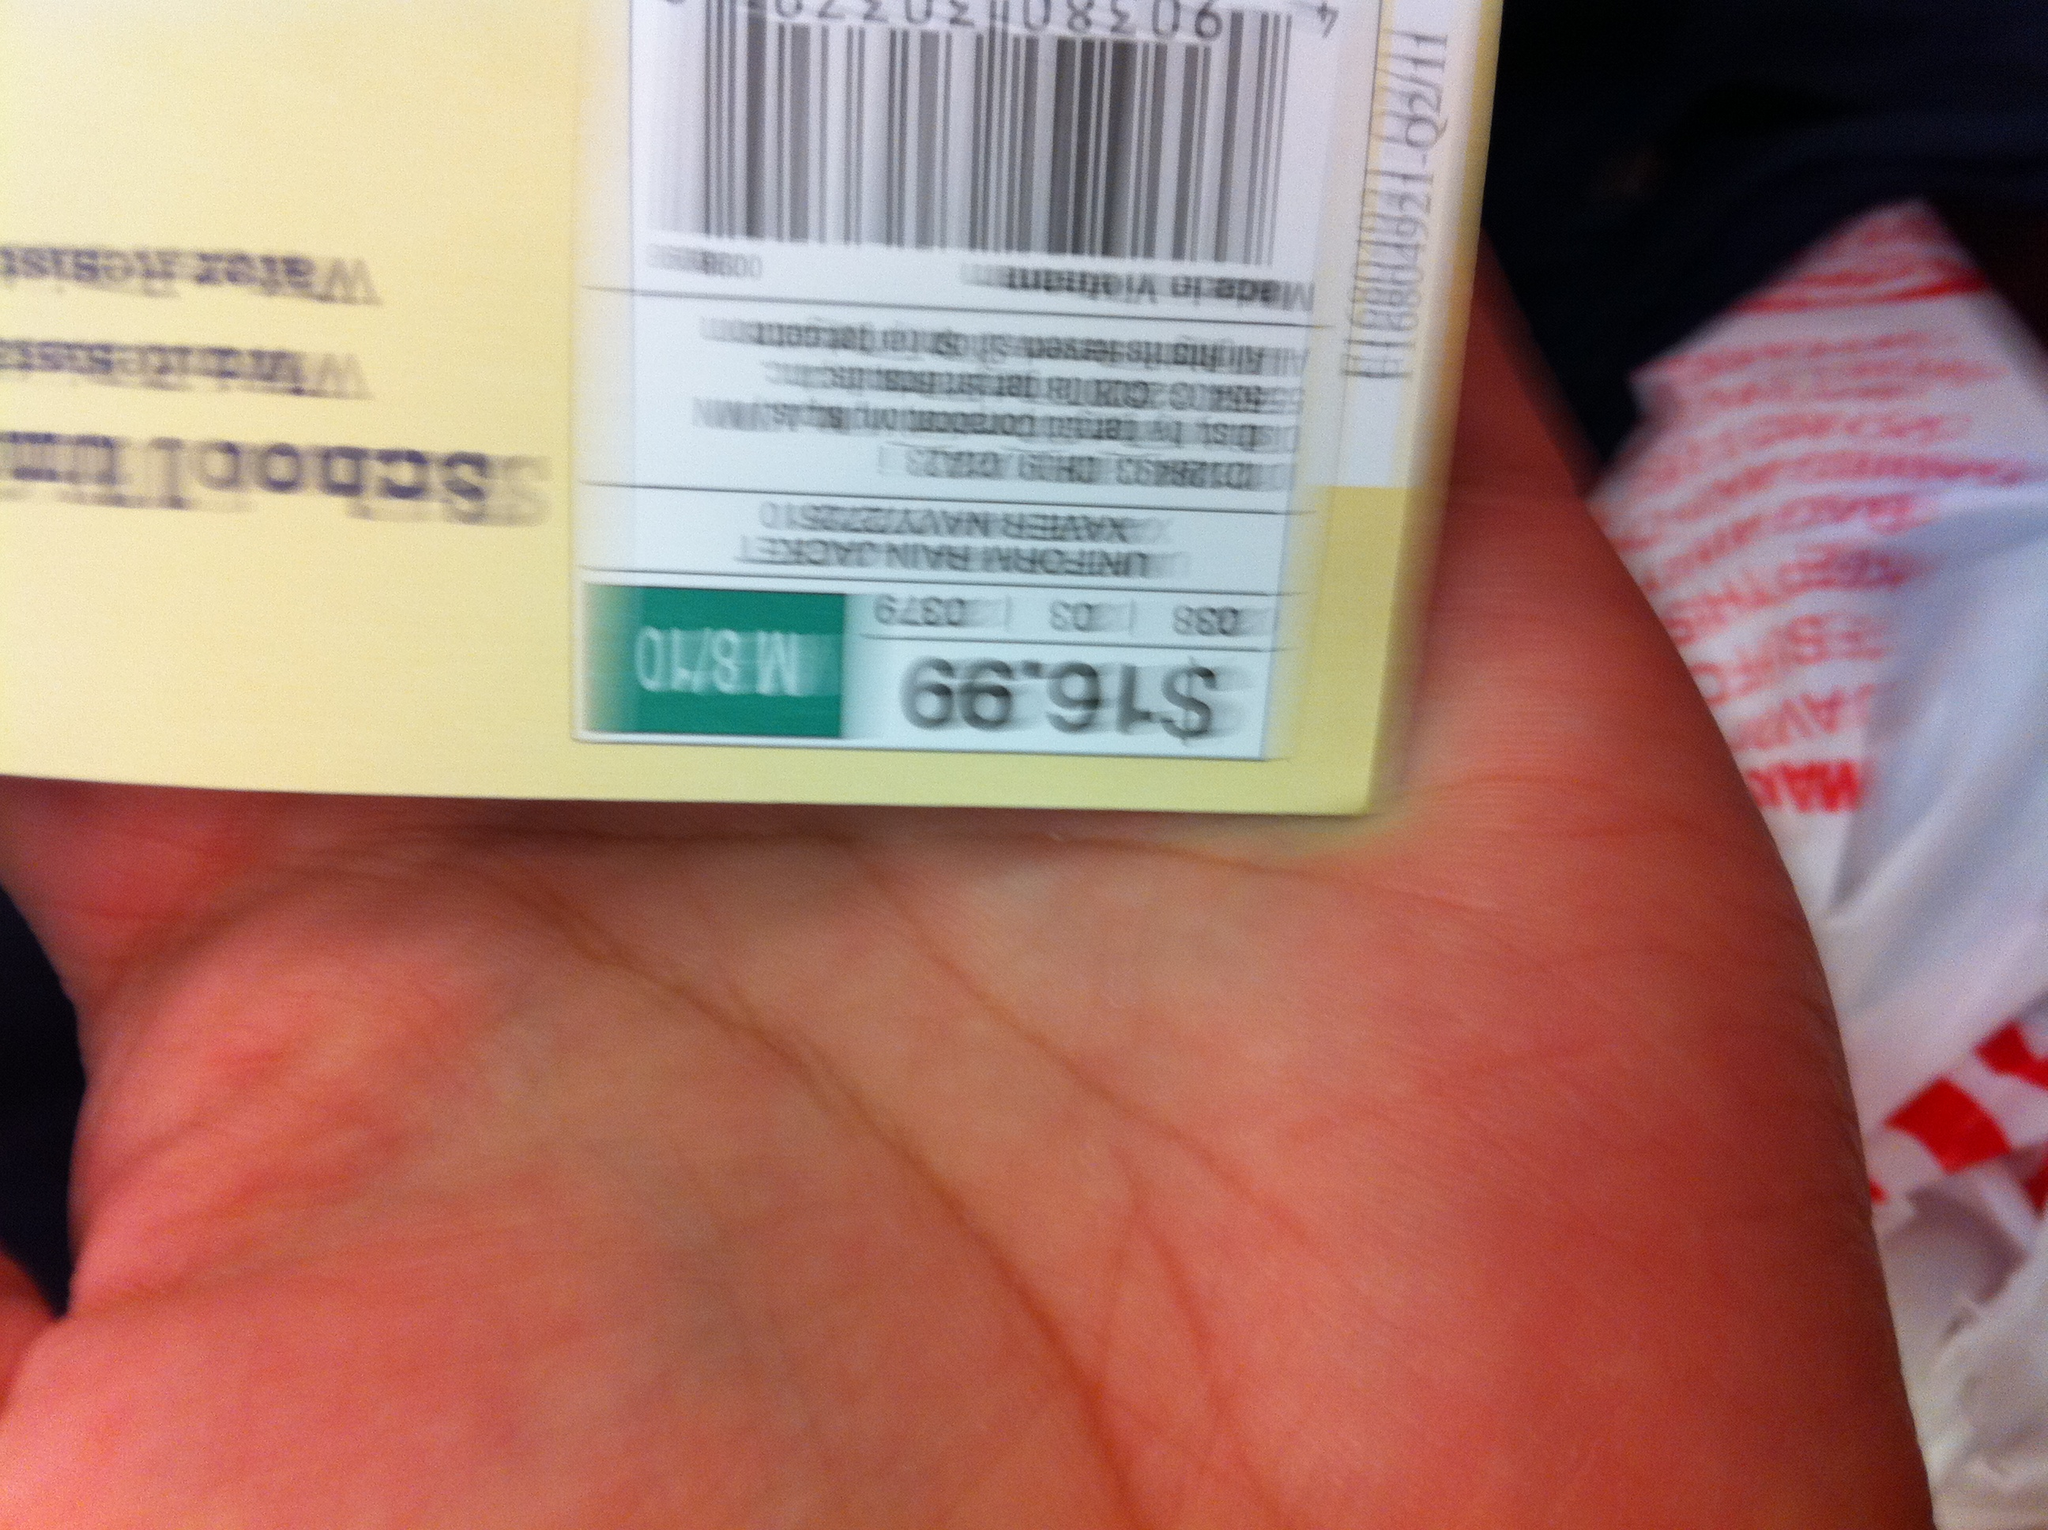Can you tell what item this tag is attached to? Based on the partial view in the image, it's difficult to determine exactly what item this is. However, given the type of price tag, it's likely attached to a piece of clothing or accessory. 